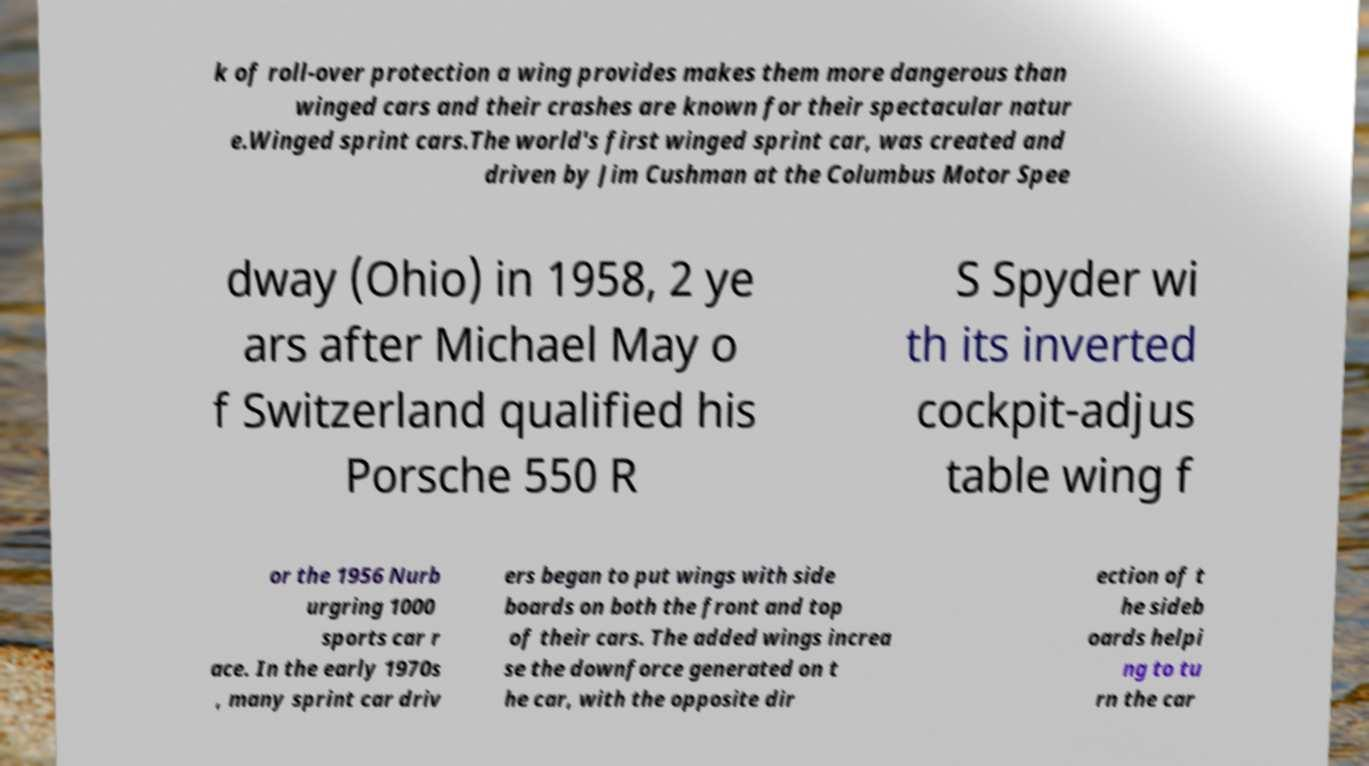What messages or text are displayed in this image? I need them in a readable, typed format. k of roll-over protection a wing provides makes them more dangerous than winged cars and their crashes are known for their spectacular natur e.Winged sprint cars.The world's first winged sprint car, was created and driven by Jim Cushman at the Columbus Motor Spee dway (Ohio) in 1958, 2 ye ars after Michael May o f Switzerland qualified his Porsche 550 R S Spyder wi th its inverted cockpit-adjus table wing f or the 1956 Nurb urgring 1000 sports car r ace. In the early 1970s , many sprint car driv ers began to put wings with side boards on both the front and top of their cars. The added wings increa se the downforce generated on t he car, with the opposite dir ection of t he sideb oards helpi ng to tu rn the car 